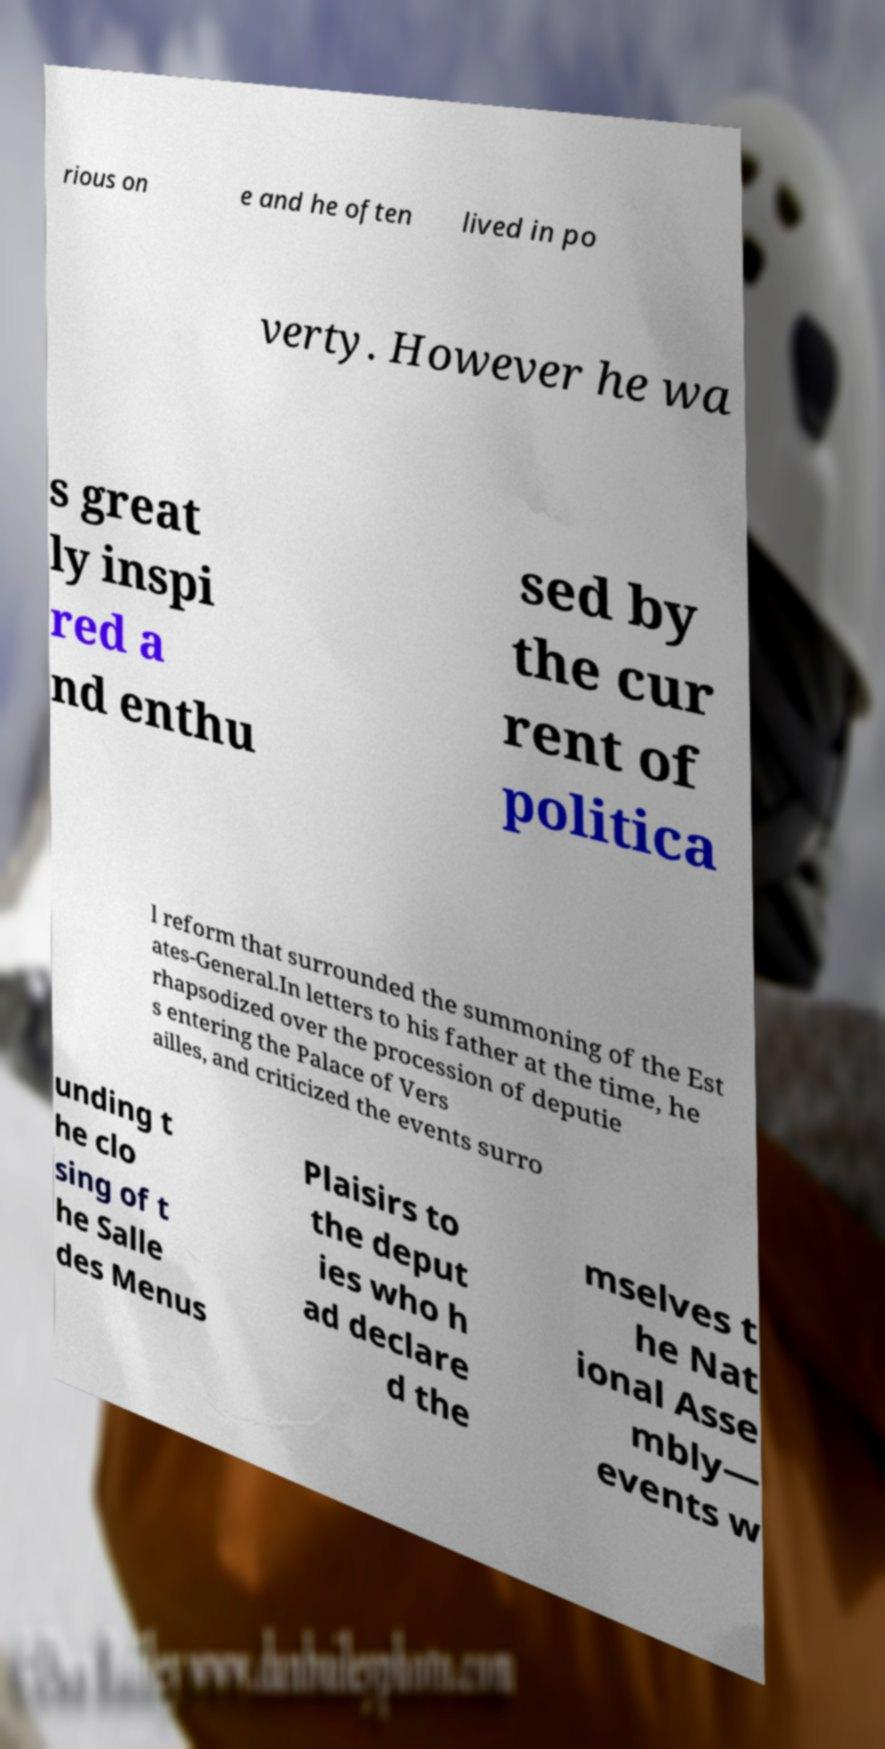Please identify and transcribe the text found in this image. rious on e and he often lived in po verty. However he wa s great ly inspi red a nd enthu sed by the cur rent of politica l reform that surrounded the summoning of the Est ates-General.In letters to his father at the time, he rhapsodized over the procession of deputie s entering the Palace of Vers ailles, and criticized the events surro unding t he clo sing of t he Salle des Menus Plaisirs to the deput ies who h ad declare d the mselves t he Nat ional Asse mbly— events w 